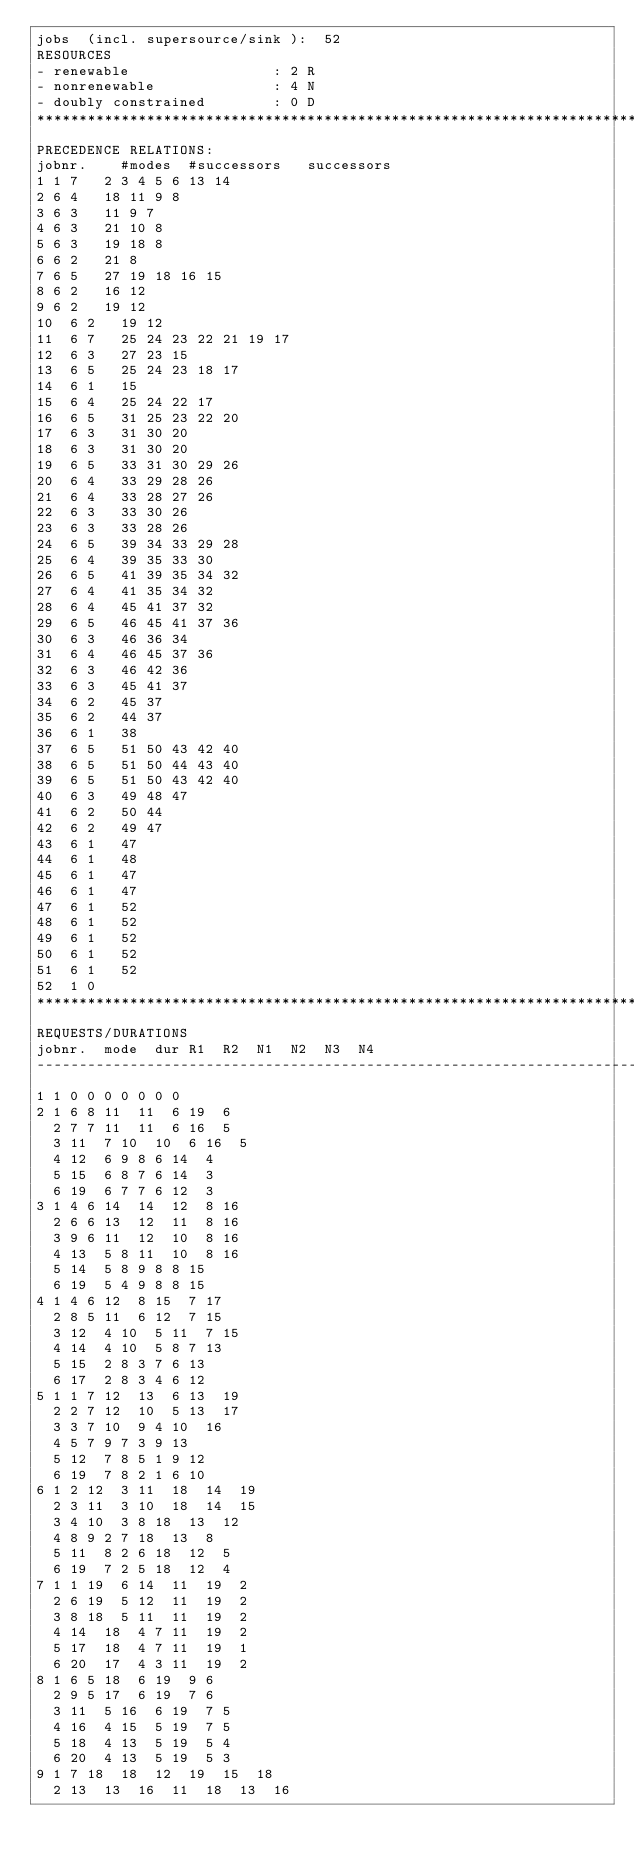<code> <loc_0><loc_0><loc_500><loc_500><_ObjectiveC_>jobs  (incl. supersource/sink ):	52
RESOURCES
- renewable                 : 2 R
- nonrenewable              : 4 N
- doubly constrained        : 0 D
************************************************************************
PRECEDENCE RELATIONS:
jobnr.    #modes  #successors   successors
1	1	7		2 3 4 5 6 13 14 
2	6	4		18 11 9 8 
3	6	3		11 9 7 
4	6	3		21 10 8 
5	6	3		19 18 8 
6	6	2		21 8 
7	6	5		27 19 18 16 15 
8	6	2		16 12 
9	6	2		19 12 
10	6	2		19 12 
11	6	7		25 24 23 22 21 19 17 
12	6	3		27 23 15 
13	6	5		25 24 23 18 17 
14	6	1		15 
15	6	4		25 24 22 17 
16	6	5		31 25 23 22 20 
17	6	3		31 30 20 
18	6	3		31 30 20 
19	6	5		33 31 30 29 26 
20	6	4		33 29 28 26 
21	6	4		33 28 27 26 
22	6	3		33 30 26 
23	6	3		33 28 26 
24	6	5		39 34 33 29 28 
25	6	4		39 35 33 30 
26	6	5		41 39 35 34 32 
27	6	4		41 35 34 32 
28	6	4		45 41 37 32 
29	6	5		46 45 41 37 36 
30	6	3		46 36 34 
31	6	4		46 45 37 36 
32	6	3		46 42 36 
33	6	3		45 41 37 
34	6	2		45 37 
35	6	2		44 37 
36	6	1		38 
37	6	5		51 50 43 42 40 
38	6	5		51 50 44 43 40 
39	6	5		51 50 43 42 40 
40	6	3		49 48 47 
41	6	2		50 44 
42	6	2		49 47 
43	6	1		47 
44	6	1		48 
45	6	1		47 
46	6	1		47 
47	6	1		52 
48	6	1		52 
49	6	1		52 
50	6	1		52 
51	6	1		52 
52	1	0		
************************************************************************
REQUESTS/DURATIONS
jobnr.	mode	dur	R1	R2	N1	N2	N3	N4	
------------------------------------------------------------------------
1	1	0	0	0	0	0	0	0	
2	1	6	8	11	11	6	19	6	
	2	7	7	11	11	6	16	5	
	3	11	7	10	10	6	16	5	
	4	12	6	9	8	6	14	4	
	5	15	6	8	7	6	14	3	
	6	19	6	7	7	6	12	3	
3	1	4	6	14	14	12	8	16	
	2	6	6	13	12	11	8	16	
	3	9	6	11	12	10	8	16	
	4	13	5	8	11	10	8	16	
	5	14	5	8	9	8	8	15	
	6	19	5	4	9	8	8	15	
4	1	4	6	12	8	15	7	17	
	2	8	5	11	6	12	7	15	
	3	12	4	10	5	11	7	15	
	4	14	4	10	5	8	7	13	
	5	15	2	8	3	7	6	13	
	6	17	2	8	3	4	6	12	
5	1	1	7	12	13	6	13	19	
	2	2	7	12	10	5	13	17	
	3	3	7	10	9	4	10	16	
	4	5	7	9	7	3	9	13	
	5	12	7	8	5	1	9	12	
	6	19	7	8	2	1	6	10	
6	1	2	12	3	11	18	14	19	
	2	3	11	3	10	18	14	15	
	3	4	10	3	8	18	13	12	
	4	8	9	2	7	18	13	8	
	5	11	8	2	6	18	12	5	
	6	19	7	2	5	18	12	4	
7	1	1	19	6	14	11	19	2	
	2	6	19	5	12	11	19	2	
	3	8	18	5	11	11	19	2	
	4	14	18	4	7	11	19	2	
	5	17	18	4	7	11	19	1	
	6	20	17	4	3	11	19	2	
8	1	6	5	18	6	19	9	6	
	2	9	5	17	6	19	7	6	
	3	11	5	16	6	19	7	5	
	4	16	4	15	5	19	7	5	
	5	18	4	13	5	19	5	4	
	6	20	4	13	5	19	5	3	
9	1	7	18	18	12	19	15	18	
	2	13	13	16	11	18	13	16	</code> 